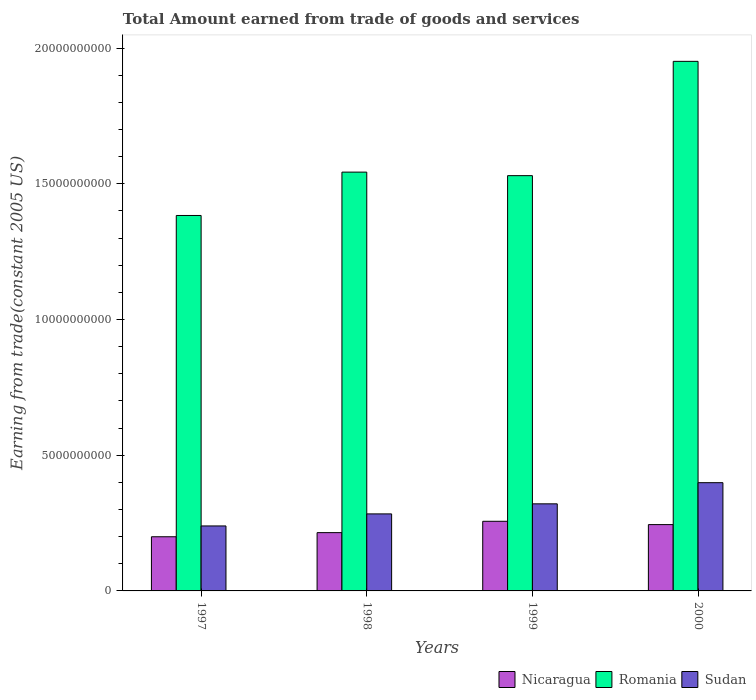How many groups of bars are there?
Keep it short and to the point. 4. Are the number of bars per tick equal to the number of legend labels?
Ensure brevity in your answer.  Yes. What is the total amount earned by trading goods and services in Romania in 1999?
Offer a very short reply. 1.53e+1. Across all years, what is the maximum total amount earned by trading goods and services in Romania?
Give a very brief answer. 1.95e+1. Across all years, what is the minimum total amount earned by trading goods and services in Romania?
Give a very brief answer. 1.38e+1. In which year was the total amount earned by trading goods and services in Nicaragua minimum?
Keep it short and to the point. 1997. What is the total total amount earned by trading goods and services in Romania in the graph?
Ensure brevity in your answer.  6.41e+1. What is the difference between the total amount earned by trading goods and services in Sudan in 1997 and that in 1999?
Your answer should be compact. -8.14e+08. What is the difference between the total amount earned by trading goods and services in Romania in 2000 and the total amount earned by trading goods and services in Sudan in 1999?
Give a very brief answer. 1.63e+1. What is the average total amount earned by trading goods and services in Sudan per year?
Offer a very short reply. 3.11e+09. In the year 1997, what is the difference between the total amount earned by trading goods and services in Nicaragua and total amount earned by trading goods and services in Sudan?
Your response must be concise. -3.98e+08. In how many years, is the total amount earned by trading goods and services in Nicaragua greater than 18000000000 US$?
Provide a short and direct response. 0. What is the ratio of the total amount earned by trading goods and services in Romania in 1997 to that in 2000?
Give a very brief answer. 0.71. Is the total amount earned by trading goods and services in Sudan in 1999 less than that in 2000?
Your answer should be very brief. Yes. What is the difference between the highest and the second highest total amount earned by trading goods and services in Romania?
Your response must be concise. 4.08e+09. What is the difference between the highest and the lowest total amount earned by trading goods and services in Nicaragua?
Provide a short and direct response. 5.70e+08. In how many years, is the total amount earned by trading goods and services in Nicaragua greater than the average total amount earned by trading goods and services in Nicaragua taken over all years?
Keep it short and to the point. 2. Is the sum of the total amount earned by trading goods and services in Sudan in 1997 and 1999 greater than the maximum total amount earned by trading goods and services in Nicaragua across all years?
Provide a succinct answer. Yes. What does the 1st bar from the left in 1997 represents?
Your response must be concise. Nicaragua. What does the 2nd bar from the right in 1998 represents?
Offer a very short reply. Romania. Is it the case that in every year, the sum of the total amount earned by trading goods and services in Sudan and total amount earned by trading goods and services in Nicaragua is greater than the total amount earned by trading goods and services in Romania?
Your response must be concise. No. How many bars are there?
Ensure brevity in your answer.  12. Are the values on the major ticks of Y-axis written in scientific E-notation?
Provide a succinct answer. No. Does the graph contain grids?
Provide a succinct answer. No. Where does the legend appear in the graph?
Your answer should be very brief. Bottom right. How many legend labels are there?
Give a very brief answer. 3. What is the title of the graph?
Your response must be concise. Total Amount earned from trade of goods and services. Does "Croatia" appear as one of the legend labels in the graph?
Offer a terse response. No. What is the label or title of the Y-axis?
Provide a succinct answer. Earning from trade(constant 2005 US). What is the Earning from trade(constant 2005 US) of Nicaragua in 1997?
Your answer should be very brief. 2.00e+09. What is the Earning from trade(constant 2005 US) of Romania in 1997?
Provide a succinct answer. 1.38e+1. What is the Earning from trade(constant 2005 US) of Sudan in 1997?
Your answer should be very brief. 2.39e+09. What is the Earning from trade(constant 2005 US) of Nicaragua in 1998?
Your answer should be compact. 2.15e+09. What is the Earning from trade(constant 2005 US) in Romania in 1998?
Give a very brief answer. 1.54e+1. What is the Earning from trade(constant 2005 US) in Sudan in 1998?
Keep it short and to the point. 2.84e+09. What is the Earning from trade(constant 2005 US) in Nicaragua in 1999?
Offer a terse response. 2.57e+09. What is the Earning from trade(constant 2005 US) in Romania in 1999?
Give a very brief answer. 1.53e+1. What is the Earning from trade(constant 2005 US) in Sudan in 1999?
Provide a short and direct response. 3.21e+09. What is the Earning from trade(constant 2005 US) in Nicaragua in 2000?
Your answer should be very brief. 2.44e+09. What is the Earning from trade(constant 2005 US) in Romania in 2000?
Offer a terse response. 1.95e+1. What is the Earning from trade(constant 2005 US) of Sudan in 2000?
Your response must be concise. 3.99e+09. Across all years, what is the maximum Earning from trade(constant 2005 US) of Nicaragua?
Keep it short and to the point. 2.57e+09. Across all years, what is the maximum Earning from trade(constant 2005 US) of Romania?
Provide a short and direct response. 1.95e+1. Across all years, what is the maximum Earning from trade(constant 2005 US) of Sudan?
Give a very brief answer. 3.99e+09. Across all years, what is the minimum Earning from trade(constant 2005 US) of Nicaragua?
Give a very brief answer. 2.00e+09. Across all years, what is the minimum Earning from trade(constant 2005 US) of Romania?
Keep it short and to the point. 1.38e+1. Across all years, what is the minimum Earning from trade(constant 2005 US) in Sudan?
Ensure brevity in your answer.  2.39e+09. What is the total Earning from trade(constant 2005 US) in Nicaragua in the graph?
Provide a short and direct response. 9.15e+09. What is the total Earning from trade(constant 2005 US) in Romania in the graph?
Give a very brief answer. 6.41e+1. What is the total Earning from trade(constant 2005 US) of Sudan in the graph?
Your response must be concise. 1.24e+1. What is the difference between the Earning from trade(constant 2005 US) of Nicaragua in 1997 and that in 1998?
Offer a very short reply. -1.52e+08. What is the difference between the Earning from trade(constant 2005 US) in Romania in 1997 and that in 1998?
Give a very brief answer. -1.60e+09. What is the difference between the Earning from trade(constant 2005 US) in Sudan in 1997 and that in 1998?
Your answer should be compact. -4.44e+08. What is the difference between the Earning from trade(constant 2005 US) of Nicaragua in 1997 and that in 1999?
Provide a succinct answer. -5.70e+08. What is the difference between the Earning from trade(constant 2005 US) of Romania in 1997 and that in 1999?
Offer a terse response. -1.47e+09. What is the difference between the Earning from trade(constant 2005 US) in Sudan in 1997 and that in 1999?
Give a very brief answer. -8.14e+08. What is the difference between the Earning from trade(constant 2005 US) of Nicaragua in 1997 and that in 2000?
Give a very brief answer. -4.48e+08. What is the difference between the Earning from trade(constant 2005 US) of Romania in 1997 and that in 2000?
Offer a very short reply. -5.68e+09. What is the difference between the Earning from trade(constant 2005 US) in Sudan in 1997 and that in 2000?
Your answer should be compact. -1.59e+09. What is the difference between the Earning from trade(constant 2005 US) of Nicaragua in 1998 and that in 1999?
Offer a very short reply. -4.18e+08. What is the difference between the Earning from trade(constant 2005 US) in Romania in 1998 and that in 1999?
Your answer should be compact. 1.31e+08. What is the difference between the Earning from trade(constant 2005 US) in Sudan in 1998 and that in 1999?
Offer a terse response. -3.70e+08. What is the difference between the Earning from trade(constant 2005 US) in Nicaragua in 1998 and that in 2000?
Your response must be concise. -2.96e+08. What is the difference between the Earning from trade(constant 2005 US) in Romania in 1998 and that in 2000?
Offer a very short reply. -4.08e+09. What is the difference between the Earning from trade(constant 2005 US) of Sudan in 1998 and that in 2000?
Ensure brevity in your answer.  -1.15e+09. What is the difference between the Earning from trade(constant 2005 US) in Nicaragua in 1999 and that in 2000?
Give a very brief answer. 1.22e+08. What is the difference between the Earning from trade(constant 2005 US) in Romania in 1999 and that in 2000?
Offer a very short reply. -4.21e+09. What is the difference between the Earning from trade(constant 2005 US) in Sudan in 1999 and that in 2000?
Offer a very short reply. -7.80e+08. What is the difference between the Earning from trade(constant 2005 US) of Nicaragua in 1997 and the Earning from trade(constant 2005 US) of Romania in 1998?
Your answer should be very brief. -1.34e+1. What is the difference between the Earning from trade(constant 2005 US) in Nicaragua in 1997 and the Earning from trade(constant 2005 US) in Sudan in 1998?
Offer a terse response. -8.42e+08. What is the difference between the Earning from trade(constant 2005 US) in Romania in 1997 and the Earning from trade(constant 2005 US) in Sudan in 1998?
Provide a succinct answer. 1.10e+1. What is the difference between the Earning from trade(constant 2005 US) in Nicaragua in 1997 and the Earning from trade(constant 2005 US) in Romania in 1999?
Make the answer very short. -1.33e+1. What is the difference between the Earning from trade(constant 2005 US) in Nicaragua in 1997 and the Earning from trade(constant 2005 US) in Sudan in 1999?
Offer a very short reply. -1.21e+09. What is the difference between the Earning from trade(constant 2005 US) of Romania in 1997 and the Earning from trade(constant 2005 US) of Sudan in 1999?
Provide a succinct answer. 1.06e+1. What is the difference between the Earning from trade(constant 2005 US) of Nicaragua in 1997 and the Earning from trade(constant 2005 US) of Romania in 2000?
Ensure brevity in your answer.  -1.75e+1. What is the difference between the Earning from trade(constant 2005 US) of Nicaragua in 1997 and the Earning from trade(constant 2005 US) of Sudan in 2000?
Make the answer very short. -1.99e+09. What is the difference between the Earning from trade(constant 2005 US) in Romania in 1997 and the Earning from trade(constant 2005 US) in Sudan in 2000?
Offer a terse response. 9.84e+09. What is the difference between the Earning from trade(constant 2005 US) of Nicaragua in 1998 and the Earning from trade(constant 2005 US) of Romania in 1999?
Offer a very short reply. -1.32e+1. What is the difference between the Earning from trade(constant 2005 US) in Nicaragua in 1998 and the Earning from trade(constant 2005 US) in Sudan in 1999?
Provide a short and direct response. -1.06e+09. What is the difference between the Earning from trade(constant 2005 US) in Romania in 1998 and the Earning from trade(constant 2005 US) in Sudan in 1999?
Your answer should be very brief. 1.22e+1. What is the difference between the Earning from trade(constant 2005 US) in Nicaragua in 1998 and the Earning from trade(constant 2005 US) in Romania in 2000?
Your answer should be very brief. -1.74e+1. What is the difference between the Earning from trade(constant 2005 US) in Nicaragua in 1998 and the Earning from trade(constant 2005 US) in Sudan in 2000?
Your response must be concise. -1.84e+09. What is the difference between the Earning from trade(constant 2005 US) in Romania in 1998 and the Earning from trade(constant 2005 US) in Sudan in 2000?
Make the answer very short. 1.14e+1. What is the difference between the Earning from trade(constant 2005 US) of Nicaragua in 1999 and the Earning from trade(constant 2005 US) of Romania in 2000?
Provide a short and direct response. -1.69e+1. What is the difference between the Earning from trade(constant 2005 US) in Nicaragua in 1999 and the Earning from trade(constant 2005 US) in Sudan in 2000?
Ensure brevity in your answer.  -1.42e+09. What is the difference between the Earning from trade(constant 2005 US) in Romania in 1999 and the Earning from trade(constant 2005 US) in Sudan in 2000?
Make the answer very short. 1.13e+1. What is the average Earning from trade(constant 2005 US) in Nicaragua per year?
Give a very brief answer. 2.29e+09. What is the average Earning from trade(constant 2005 US) in Romania per year?
Your response must be concise. 1.60e+1. What is the average Earning from trade(constant 2005 US) in Sudan per year?
Provide a succinct answer. 3.11e+09. In the year 1997, what is the difference between the Earning from trade(constant 2005 US) of Nicaragua and Earning from trade(constant 2005 US) of Romania?
Ensure brevity in your answer.  -1.18e+1. In the year 1997, what is the difference between the Earning from trade(constant 2005 US) of Nicaragua and Earning from trade(constant 2005 US) of Sudan?
Keep it short and to the point. -3.98e+08. In the year 1997, what is the difference between the Earning from trade(constant 2005 US) of Romania and Earning from trade(constant 2005 US) of Sudan?
Your answer should be compact. 1.14e+1. In the year 1998, what is the difference between the Earning from trade(constant 2005 US) of Nicaragua and Earning from trade(constant 2005 US) of Romania?
Your response must be concise. -1.33e+1. In the year 1998, what is the difference between the Earning from trade(constant 2005 US) of Nicaragua and Earning from trade(constant 2005 US) of Sudan?
Provide a short and direct response. -6.90e+08. In the year 1998, what is the difference between the Earning from trade(constant 2005 US) in Romania and Earning from trade(constant 2005 US) in Sudan?
Your answer should be very brief. 1.26e+1. In the year 1999, what is the difference between the Earning from trade(constant 2005 US) of Nicaragua and Earning from trade(constant 2005 US) of Romania?
Offer a very short reply. -1.27e+1. In the year 1999, what is the difference between the Earning from trade(constant 2005 US) of Nicaragua and Earning from trade(constant 2005 US) of Sudan?
Your answer should be very brief. -6.43e+08. In the year 1999, what is the difference between the Earning from trade(constant 2005 US) in Romania and Earning from trade(constant 2005 US) in Sudan?
Provide a succinct answer. 1.21e+1. In the year 2000, what is the difference between the Earning from trade(constant 2005 US) of Nicaragua and Earning from trade(constant 2005 US) of Romania?
Provide a succinct answer. -1.71e+1. In the year 2000, what is the difference between the Earning from trade(constant 2005 US) in Nicaragua and Earning from trade(constant 2005 US) in Sudan?
Give a very brief answer. -1.54e+09. In the year 2000, what is the difference between the Earning from trade(constant 2005 US) in Romania and Earning from trade(constant 2005 US) in Sudan?
Offer a very short reply. 1.55e+1. What is the ratio of the Earning from trade(constant 2005 US) in Nicaragua in 1997 to that in 1998?
Your response must be concise. 0.93. What is the ratio of the Earning from trade(constant 2005 US) of Romania in 1997 to that in 1998?
Your answer should be very brief. 0.9. What is the ratio of the Earning from trade(constant 2005 US) of Sudan in 1997 to that in 1998?
Make the answer very short. 0.84. What is the ratio of the Earning from trade(constant 2005 US) of Nicaragua in 1997 to that in 1999?
Provide a short and direct response. 0.78. What is the ratio of the Earning from trade(constant 2005 US) of Romania in 1997 to that in 1999?
Your response must be concise. 0.9. What is the ratio of the Earning from trade(constant 2005 US) in Sudan in 1997 to that in 1999?
Ensure brevity in your answer.  0.75. What is the ratio of the Earning from trade(constant 2005 US) of Nicaragua in 1997 to that in 2000?
Provide a short and direct response. 0.82. What is the ratio of the Earning from trade(constant 2005 US) in Romania in 1997 to that in 2000?
Provide a succinct answer. 0.71. What is the ratio of the Earning from trade(constant 2005 US) of Sudan in 1997 to that in 2000?
Provide a succinct answer. 0.6. What is the ratio of the Earning from trade(constant 2005 US) of Nicaragua in 1998 to that in 1999?
Keep it short and to the point. 0.84. What is the ratio of the Earning from trade(constant 2005 US) of Romania in 1998 to that in 1999?
Make the answer very short. 1.01. What is the ratio of the Earning from trade(constant 2005 US) of Sudan in 1998 to that in 1999?
Give a very brief answer. 0.88. What is the ratio of the Earning from trade(constant 2005 US) in Nicaragua in 1998 to that in 2000?
Provide a short and direct response. 0.88. What is the ratio of the Earning from trade(constant 2005 US) of Romania in 1998 to that in 2000?
Provide a short and direct response. 0.79. What is the ratio of the Earning from trade(constant 2005 US) of Sudan in 1998 to that in 2000?
Ensure brevity in your answer.  0.71. What is the ratio of the Earning from trade(constant 2005 US) of Nicaragua in 1999 to that in 2000?
Keep it short and to the point. 1.05. What is the ratio of the Earning from trade(constant 2005 US) of Romania in 1999 to that in 2000?
Offer a terse response. 0.78. What is the ratio of the Earning from trade(constant 2005 US) of Sudan in 1999 to that in 2000?
Give a very brief answer. 0.8. What is the difference between the highest and the second highest Earning from trade(constant 2005 US) of Nicaragua?
Your response must be concise. 1.22e+08. What is the difference between the highest and the second highest Earning from trade(constant 2005 US) of Romania?
Your answer should be very brief. 4.08e+09. What is the difference between the highest and the second highest Earning from trade(constant 2005 US) of Sudan?
Keep it short and to the point. 7.80e+08. What is the difference between the highest and the lowest Earning from trade(constant 2005 US) in Nicaragua?
Give a very brief answer. 5.70e+08. What is the difference between the highest and the lowest Earning from trade(constant 2005 US) of Romania?
Give a very brief answer. 5.68e+09. What is the difference between the highest and the lowest Earning from trade(constant 2005 US) of Sudan?
Provide a short and direct response. 1.59e+09. 